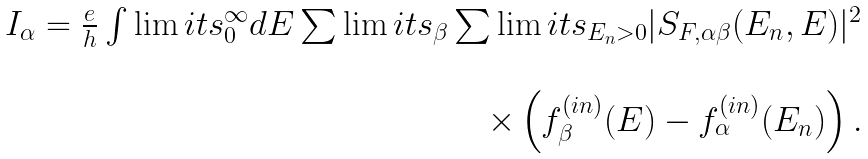Convert formula to latex. <formula><loc_0><loc_0><loc_500><loc_500>\begin{array} { r } I _ { \alpha } = \frac { e } { h } \int \lim i t s _ { 0 } ^ { \infty } d E \sum \lim i t s _ { \beta } \sum \lim i t s _ { E _ { n } > 0 } | S _ { F , \alpha \beta } ( E _ { n } , E ) | ^ { 2 } \\ \ \\ \times \left ( f ^ { ( i n ) } _ { \beta } ( E ) - f ^ { ( i n ) } _ { \alpha } ( E _ { n } ) \right ) . \end{array}</formula> 